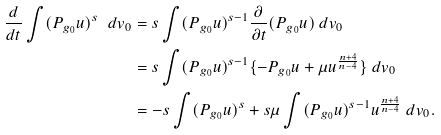<formula> <loc_0><loc_0><loc_500><loc_500>\frac { d } { d t } \int ( P _ { g _ { 0 } } u ) ^ { s } \ d v _ { 0 } & = s \int ( P _ { g _ { 0 } } u ) ^ { s - 1 } \frac { \partial } { \partial t } ( P _ { g _ { 0 } } u ) \ d v _ { 0 } \\ & = s \int ( P _ { g _ { 0 } } u ) ^ { s - 1 } \{ - P _ { g _ { 0 } } u + \mu u ^ { \frac { n + 4 } { n - 4 } } \} \ d v _ { 0 } \\ & = - s \int ( P _ { g _ { 0 } } u ) ^ { s } + s \mu \int ( P _ { g _ { 0 } } u ) ^ { s - 1 } u ^ { \frac { n + 4 } { n - 4 } } \ d v _ { 0 } .</formula> 